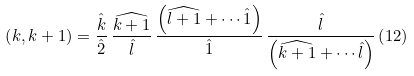Convert formula to latex. <formula><loc_0><loc_0><loc_500><loc_500>\left ( k , k + 1 \right ) = \frac { \hat { k } } { \hat { 2 } } \, \frac { \widehat { k + 1 } } { \hat { l } } \, \frac { \left ( \widehat { l + 1 } + \cdots \hat { 1 } \right ) } { \hat { 1 } } \, \frac { \hat { l } } { \left ( \widehat { k + 1 } + \cdots \hat { l } \right ) } \left ( 1 2 \right )</formula> 